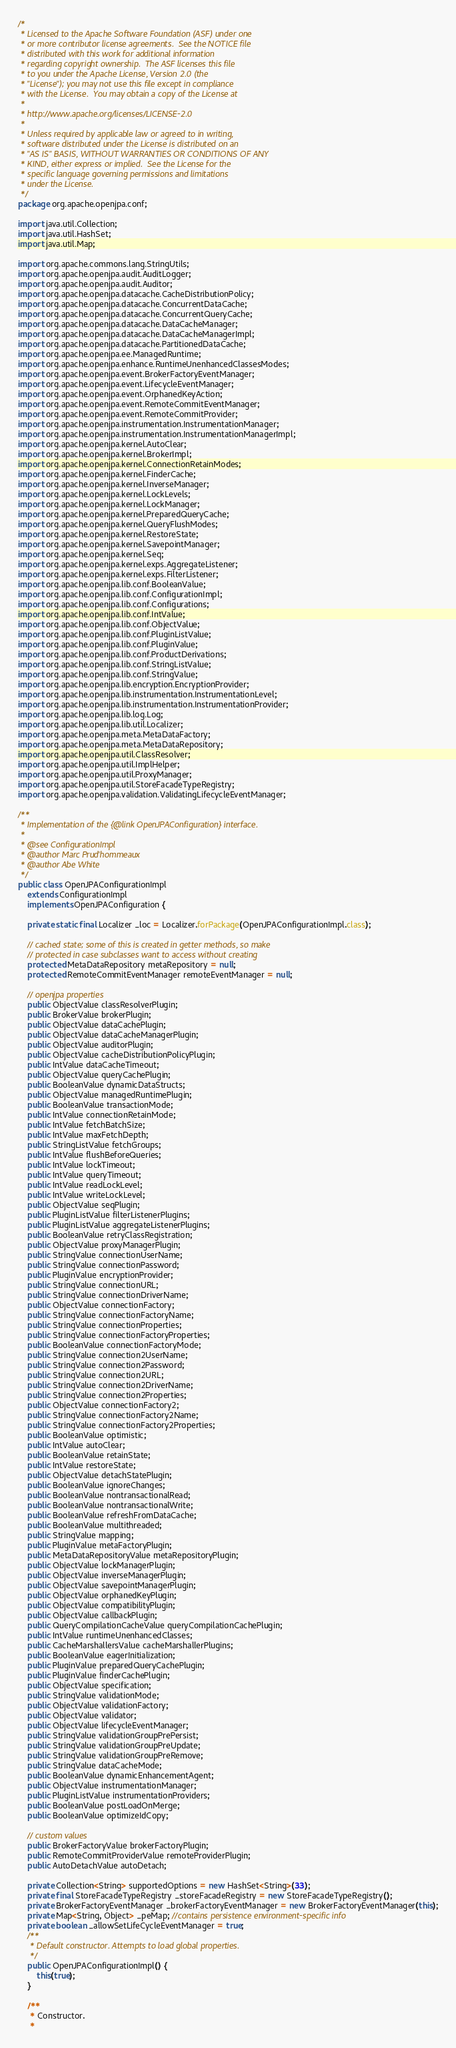<code> <loc_0><loc_0><loc_500><loc_500><_Java_>/*
 * Licensed to the Apache Software Foundation (ASF) under one
 * or more contributor license agreements.  See the NOTICE file
 * distributed with this work for additional information
 * regarding copyright ownership.  The ASF licenses this file
 * to you under the Apache License, Version 2.0 (the
 * "License"); you may not use this file except in compliance
 * with the License.  You may obtain a copy of the License at
 *
 * http://www.apache.org/licenses/LICENSE-2.0
 *
 * Unless required by applicable law or agreed to in writing,
 * software distributed under the License is distributed on an
 * "AS IS" BASIS, WITHOUT WARRANTIES OR CONDITIONS OF ANY
 * KIND, either express or implied.  See the License for the
 * specific language governing permissions and limitations
 * under the License.    
 */
package org.apache.openjpa.conf;

import java.util.Collection;
import java.util.HashSet;
import java.util.Map;

import org.apache.commons.lang.StringUtils;
import org.apache.openjpa.audit.AuditLogger;
import org.apache.openjpa.audit.Auditor;
import org.apache.openjpa.datacache.CacheDistributionPolicy;
import org.apache.openjpa.datacache.ConcurrentDataCache;
import org.apache.openjpa.datacache.ConcurrentQueryCache;
import org.apache.openjpa.datacache.DataCacheManager;
import org.apache.openjpa.datacache.DataCacheManagerImpl;
import org.apache.openjpa.datacache.PartitionedDataCache;
import org.apache.openjpa.ee.ManagedRuntime;
import org.apache.openjpa.enhance.RuntimeUnenhancedClassesModes;
import org.apache.openjpa.event.BrokerFactoryEventManager;
import org.apache.openjpa.event.LifecycleEventManager;
import org.apache.openjpa.event.OrphanedKeyAction;
import org.apache.openjpa.event.RemoteCommitEventManager;
import org.apache.openjpa.event.RemoteCommitProvider;
import org.apache.openjpa.instrumentation.InstrumentationManager;
import org.apache.openjpa.instrumentation.InstrumentationManagerImpl;
import org.apache.openjpa.kernel.AutoClear;
import org.apache.openjpa.kernel.BrokerImpl;
import org.apache.openjpa.kernel.ConnectionRetainModes;
import org.apache.openjpa.kernel.FinderCache;
import org.apache.openjpa.kernel.InverseManager;
import org.apache.openjpa.kernel.LockLevels;
import org.apache.openjpa.kernel.LockManager;
import org.apache.openjpa.kernel.PreparedQueryCache;
import org.apache.openjpa.kernel.QueryFlushModes;
import org.apache.openjpa.kernel.RestoreState;
import org.apache.openjpa.kernel.SavepointManager;
import org.apache.openjpa.kernel.Seq;
import org.apache.openjpa.kernel.exps.AggregateListener;
import org.apache.openjpa.kernel.exps.FilterListener;
import org.apache.openjpa.lib.conf.BooleanValue;
import org.apache.openjpa.lib.conf.ConfigurationImpl;
import org.apache.openjpa.lib.conf.Configurations;
import org.apache.openjpa.lib.conf.IntValue;
import org.apache.openjpa.lib.conf.ObjectValue;
import org.apache.openjpa.lib.conf.PluginListValue;
import org.apache.openjpa.lib.conf.PluginValue;
import org.apache.openjpa.lib.conf.ProductDerivations;
import org.apache.openjpa.lib.conf.StringListValue;
import org.apache.openjpa.lib.conf.StringValue;
import org.apache.openjpa.lib.encryption.EncryptionProvider;
import org.apache.openjpa.lib.instrumentation.InstrumentationLevel;
import org.apache.openjpa.lib.instrumentation.InstrumentationProvider;
import org.apache.openjpa.lib.log.Log;
import org.apache.openjpa.lib.util.Localizer;
import org.apache.openjpa.meta.MetaDataFactory;
import org.apache.openjpa.meta.MetaDataRepository;
import org.apache.openjpa.util.ClassResolver;
import org.apache.openjpa.util.ImplHelper;
import org.apache.openjpa.util.ProxyManager;
import org.apache.openjpa.util.StoreFacadeTypeRegistry;
import org.apache.openjpa.validation.ValidatingLifecycleEventManager;

/**
 * Implementation of the {@link OpenJPAConfiguration} interface.
 *
 * @see ConfigurationImpl
 * @author Marc Prud'hommeaux
 * @author Abe White
 */
public class OpenJPAConfigurationImpl
    extends ConfigurationImpl
    implements OpenJPAConfiguration {

    private static final Localizer _loc = Localizer.forPackage(OpenJPAConfigurationImpl.class);

    // cached state; some of this is created in getter methods, so make
    // protected in case subclasses want to access without creating
    protected MetaDataRepository metaRepository = null;
    protected RemoteCommitEventManager remoteEventManager = null;

    // openjpa properties
    public ObjectValue classResolverPlugin;
    public BrokerValue brokerPlugin;
    public ObjectValue dataCachePlugin;
    public ObjectValue dataCacheManagerPlugin;
    public ObjectValue auditorPlugin;
    public ObjectValue cacheDistributionPolicyPlugin;
    public IntValue dataCacheTimeout;
    public ObjectValue queryCachePlugin;
    public BooleanValue dynamicDataStructs;
    public ObjectValue managedRuntimePlugin;
    public BooleanValue transactionMode;
    public IntValue connectionRetainMode;
    public IntValue fetchBatchSize;
    public IntValue maxFetchDepth;
    public StringListValue fetchGroups;
    public IntValue flushBeforeQueries;
    public IntValue lockTimeout;
    public IntValue queryTimeout;
    public IntValue readLockLevel;
    public IntValue writeLockLevel;
    public ObjectValue seqPlugin;
    public PluginListValue filterListenerPlugins;
    public PluginListValue aggregateListenerPlugins;
    public BooleanValue retryClassRegistration;
    public ObjectValue proxyManagerPlugin;
    public StringValue connectionUserName;
    public StringValue connectionPassword;
    public PluginValue encryptionProvider;
    public StringValue connectionURL;
    public StringValue connectionDriverName;
    public ObjectValue connectionFactory;
    public StringValue connectionFactoryName;
    public StringValue connectionProperties;
    public StringValue connectionFactoryProperties;
    public BooleanValue connectionFactoryMode;
    public StringValue connection2UserName;
    public StringValue connection2Password;
    public StringValue connection2URL;
    public StringValue connection2DriverName;
    public StringValue connection2Properties;
    public ObjectValue connectionFactory2;
    public StringValue connectionFactory2Name;
    public StringValue connectionFactory2Properties;
    public BooleanValue optimistic;
    public IntValue autoClear;
    public BooleanValue retainState;
    public IntValue restoreState;
    public ObjectValue detachStatePlugin;
    public BooleanValue ignoreChanges;
    public BooleanValue nontransactionalRead;
    public BooleanValue nontransactionalWrite;
    public BooleanValue refreshFromDataCache;
    public BooleanValue multithreaded;
    public StringValue mapping;
    public PluginValue metaFactoryPlugin;
    public MetaDataRepositoryValue metaRepositoryPlugin;
    public ObjectValue lockManagerPlugin;
    public ObjectValue inverseManagerPlugin;
    public ObjectValue savepointManagerPlugin;
    public ObjectValue orphanedKeyPlugin;
    public ObjectValue compatibilityPlugin;
    public ObjectValue callbackPlugin;
    public QueryCompilationCacheValue queryCompilationCachePlugin;
    public IntValue runtimeUnenhancedClasses;
    public CacheMarshallersValue cacheMarshallerPlugins;
    public BooleanValue eagerInitialization;
    public PluginValue preparedQueryCachePlugin;
    public PluginValue finderCachePlugin;
    public ObjectValue specification;
    public StringValue validationMode;
    public ObjectValue validationFactory;
    public ObjectValue validator;
    public ObjectValue lifecycleEventManager;
    public StringValue validationGroupPrePersist;
    public StringValue validationGroupPreUpdate;
    public StringValue validationGroupPreRemove;
    public StringValue dataCacheMode; 
    public BooleanValue dynamicEnhancementAgent;
    public ObjectValue instrumentationManager;
    public PluginListValue instrumentationProviders;
    public BooleanValue postLoadOnMerge;
    public BooleanValue optimizeIdCopy;
    
    // custom values
    public BrokerFactoryValue brokerFactoryPlugin;
    public RemoteCommitProviderValue remoteProviderPlugin;
    public AutoDetachValue autoDetach;

    private Collection<String> supportedOptions = new HashSet<String>(33);
    private final StoreFacadeTypeRegistry _storeFacadeRegistry = new StoreFacadeTypeRegistry();
    private BrokerFactoryEventManager _brokerFactoryEventManager = new BrokerFactoryEventManager(this);
    private Map<String, Object> _peMap; //contains persistence environment-specific info    
    private boolean _allowSetLifeCycleEventManager = true;
    /**
     * Default constructor. Attempts to load global properties.
     */
    public OpenJPAConfigurationImpl() {
        this(true);
    }

    /**
     * Constructor.
     *</code> 